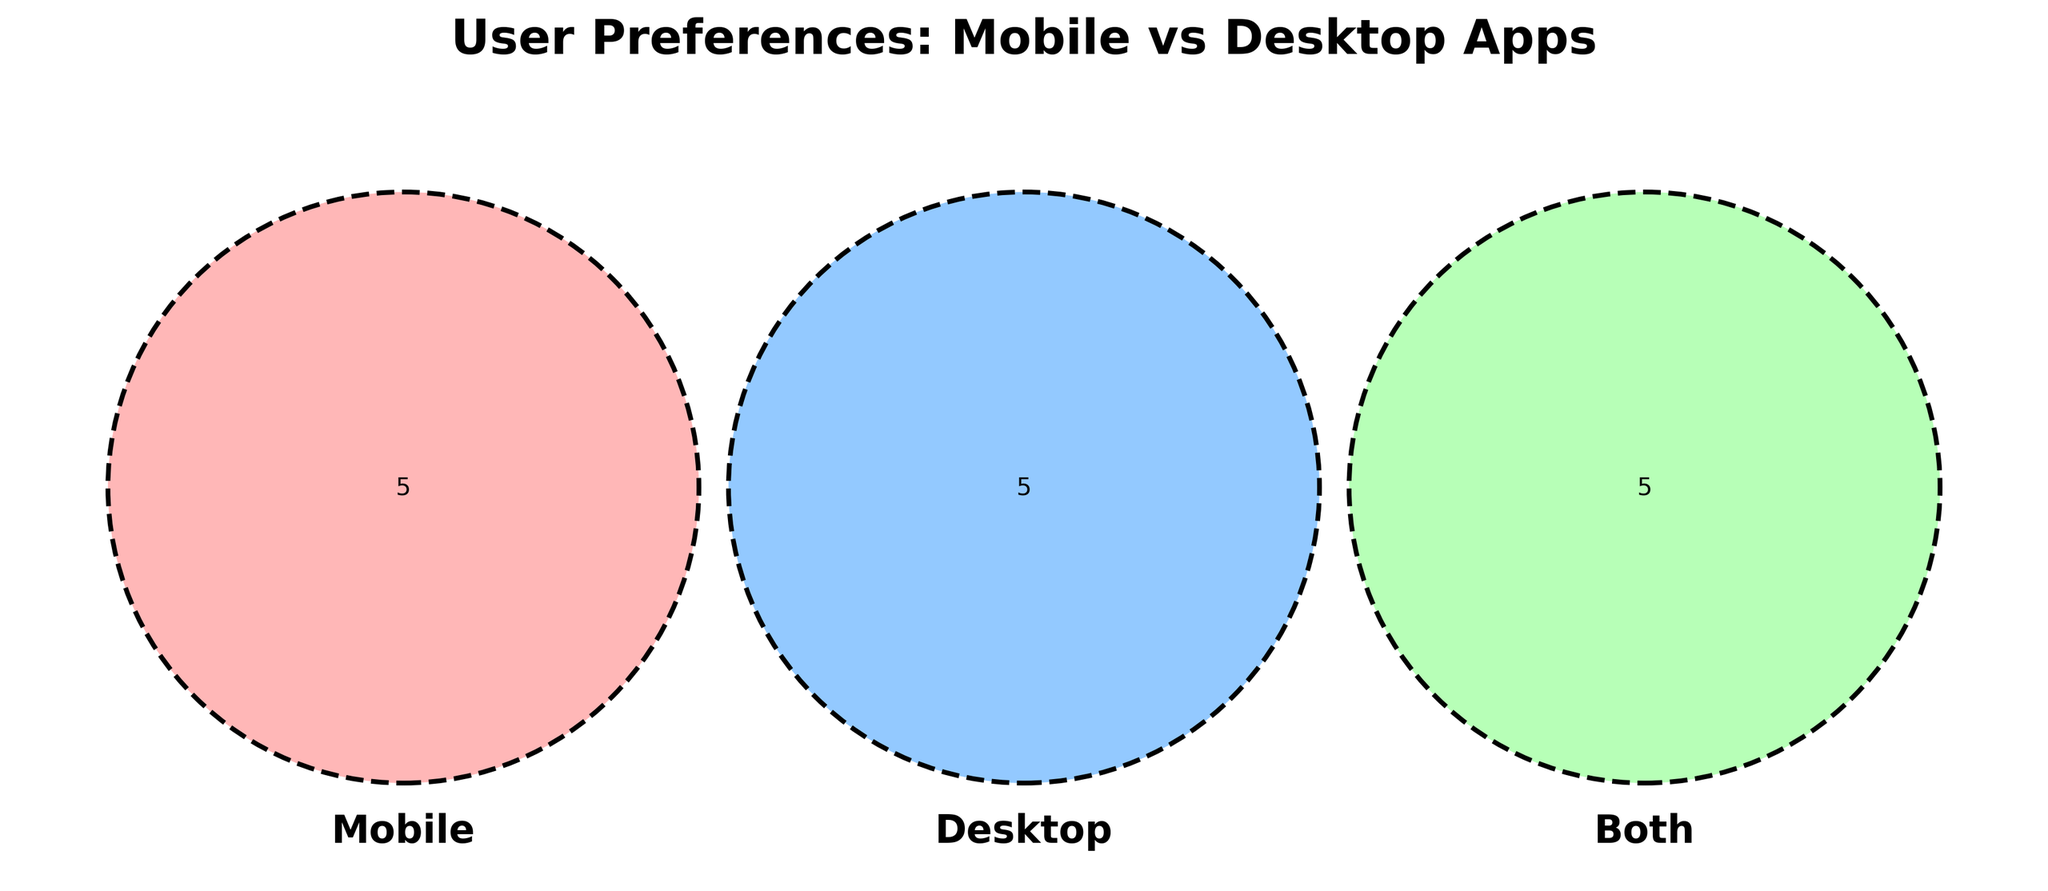What is the title of the figure? The title is typically displayed at the top of the figure. It provides a summary of the content or purpose of the visual. Here, it reads "User Preferences: Mobile vs Desktop Apps".
Answer: User Preferences: Mobile vs Desktop Apps Which set is represented by the red circle? Venn diagrams use distinct colors to represent different sets. Here, the red circle corresponds to the "Mobile" set.
Answer: Mobile What apps are preferred on both Mobile and Desktop? The section where the circles representing Mobile and Desktop overlap contains the apps preferred on both platforms. This includes Web browsers, Email clients, Cloud storage, Productivity apps, and Project management.
Answer: Web browsers, Email clients, Cloud storage, Productivity apps, Project management How many app categories are unique to Desktop? To find this, look at the section of the Venn diagram that only overlaps with the Desktop circle. This includes Office suites, Video editing software, Graphic design tools, Code editors, and Data analysis tools. There are five total categories.
Answer: 5 Which platform has the largest number of unique app preferences? Compare the non-overlapping sections of Mobile and Desktop. Mobile has five categories: Social media apps, Messaging apps, Fitness trackers, Mobile games, and Navigation apps. Desktop also has five categories. Therefore, they are equal.
Answer: Equal What are examples of productivity apps used on both platforms? Look in the overlap area labeled "Both" for productivity apps. These include Cloud storage and Productivity apps.
Answer: Cloud storage, Productivity apps Which category appears in all sets? Identifying an app category that appears in all parts of the Venn diagram means looking for the central intersection of the three circles. Here, there is no app category listed that appears in all three sets.
Answer: None Can you list a type of app exclusive to mobile but not preferred in both categories? Checking the section of the circle uniquely representing Mobile reveals Social media apps, Messaging apps, Fitness trackers, Mobile games, and Navigation apps.
Answer: Social media apps, Messaging apps, Fitness trackers, Mobile games, Navigation apps Which section of the diagram is the smallest? The smallest section is typically the intersection area that contains the fewest elements. In this case, the "Mobile" section, "Desktop" section, and the "Both" are equal. Therefore, all sections have an equal count of apps (five each).
Answer: Equal 